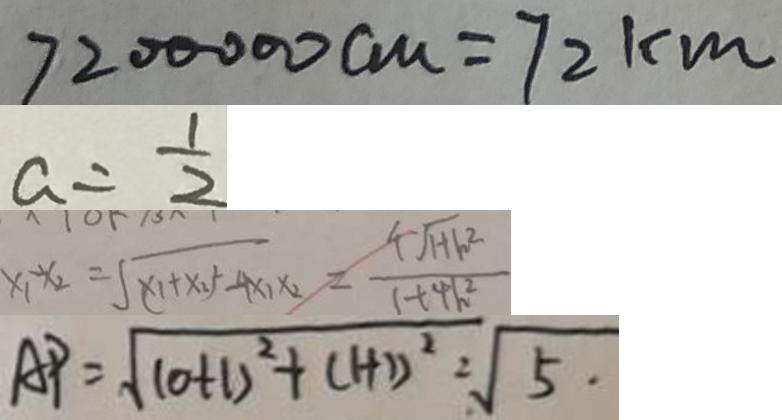<formula> <loc_0><loc_0><loc_500><loc_500>7 2 0 0 0 0 0 c m = 7 2 k m 
 a = \frac { 1 } { 2 } 
 x _ { 1 } - x _ { 2 } = \sqrt { ( x _ { 1 } + x _ { 2 } ) ^ { 2 } - 4 x _ { 1 } x _ { 2 } } = \frac { 4 \sqrt { 1 + h ^ { 2 } } } { 1 + 4 h ^ { 2 } } 
 A P = \sqrt { ( 0 + 1 ) ^ { 2 } + ( 1 + 1 ) ^ { 2 } } = \sqrt { 5 } .</formula> 